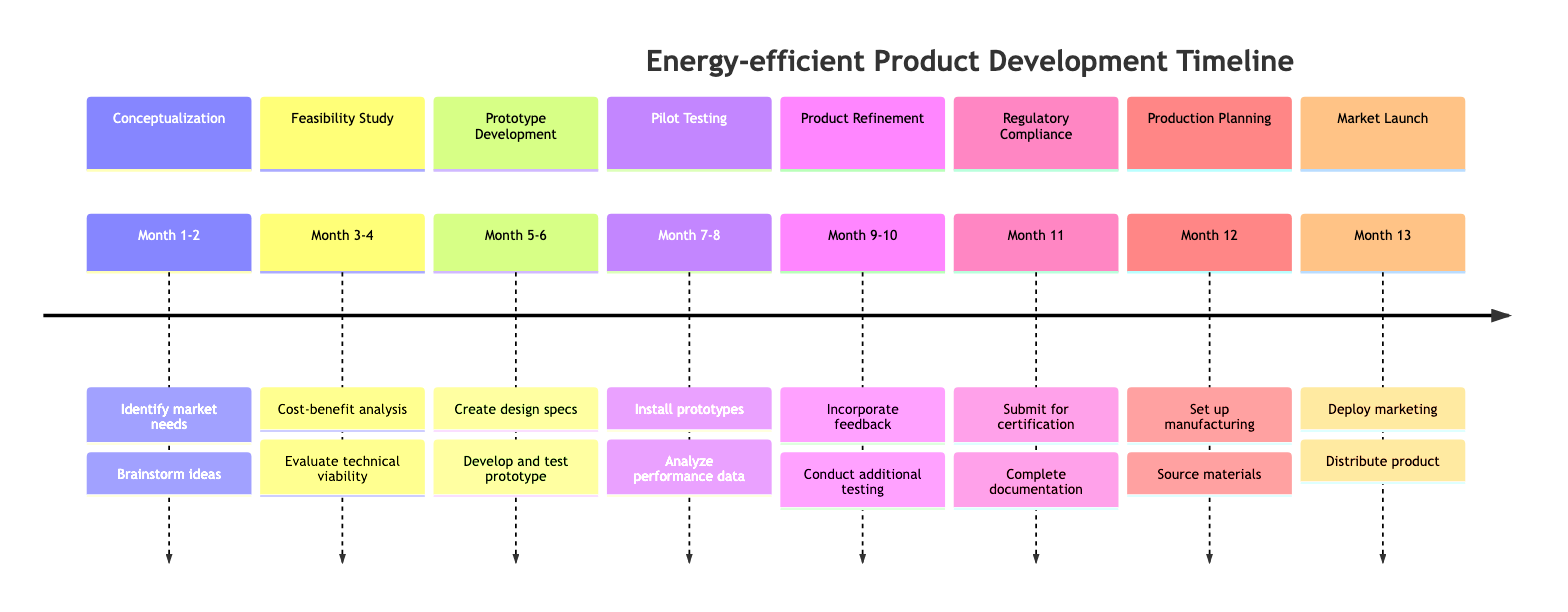What is the first stage in the timeline? The first stage is listed at the top of the timeline, which is "Conceptualization".
Answer: Conceptualization How long does the "Pilot Testing" stage last? The "Pilot Testing" stage is indicated to take two months: "Month 7-8".
Answer: Month 7-8 What milestone comes immediately before "Market Launch"? The diagram shows that "Production Planning" occurs just before the "Market Launch" stage.
Answer: Production Planning How many stages are included in this timeline? By counting the number of labeled stages in the timeline, we establish there are eight distinct stages listed.
Answer: 8 What tasks are included in the "Feasibility Study" stage? The tasks for the "Feasibility Study" stage are visible under this stage and include "Cost-benefit analysis" and "Evaluate technical viability".
Answer: Cost-benefit analysis, Evaluate technical viability Which milestone focuses on gathering feedback from real-world testing? The "Pilot Testing" milestone explicitly addresses the collaboration with small businesses to gather performance data and feedback.
Answer: Pilot Testing During which month does the "Regulatory Compliance" stage take place? The "Regulatory Compliance" stage is specifically noted to occur in "Month 11".
Answer: Month 11 What is the primary goal of the "Product Refinement" stage? The focus of the "Product Refinement" stage is to incorporate feedback from pilot testing and optimize the product for production.
Answer: Incorporate feedback, optimize for production What follows after submitting for certification? According to the timeline, after submitting for certification in the "Regulatory Compliance" stage, the next step is completing documentation for regulatory compliance.
Answer: Complete documentation 